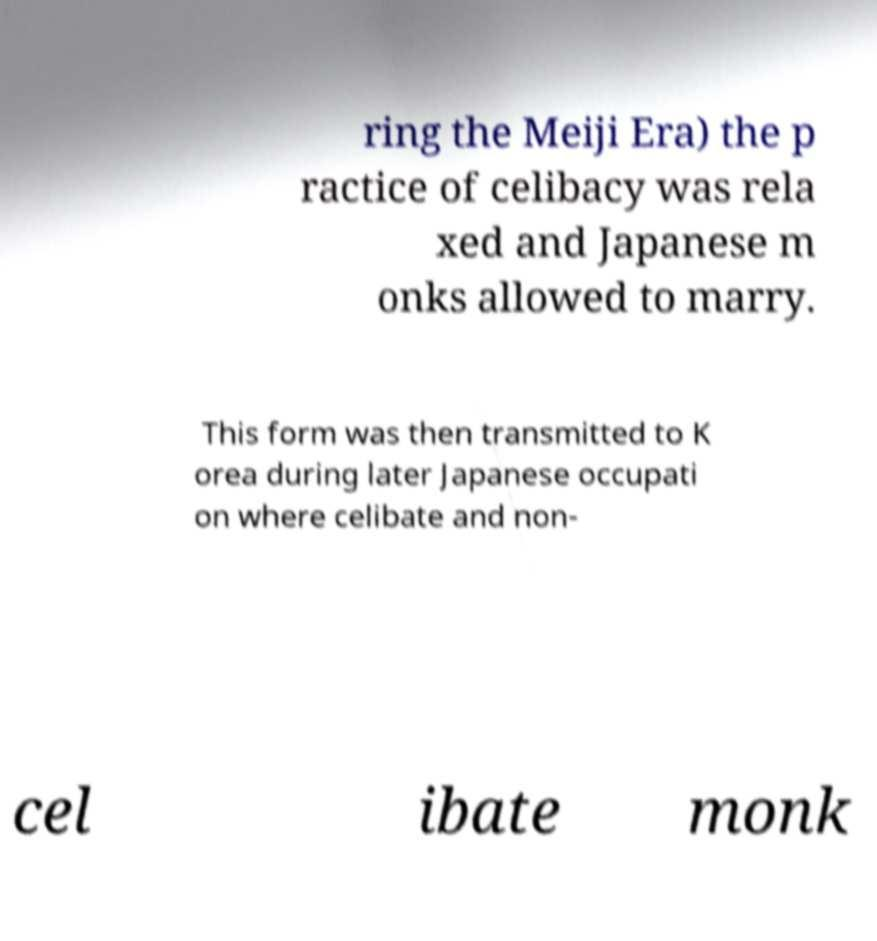There's text embedded in this image that I need extracted. Can you transcribe it verbatim? ring the Meiji Era) the p ractice of celibacy was rela xed and Japanese m onks allowed to marry. This form was then transmitted to K orea during later Japanese occupati on where celibate and non- cel ibate monk 